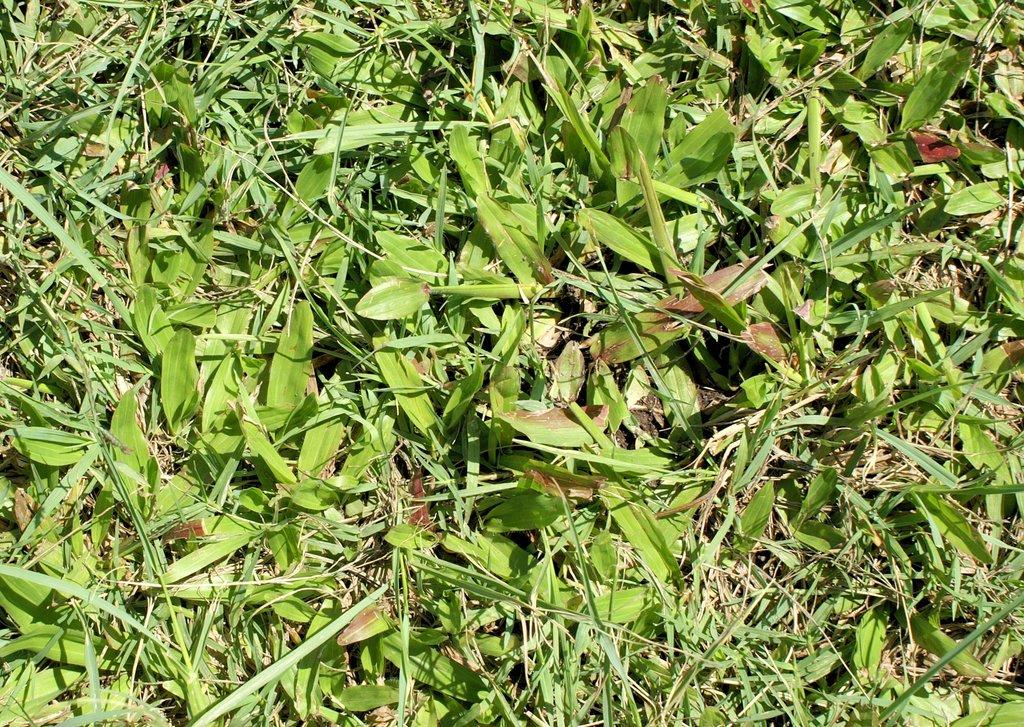What type of vegetation is present in the image? There is grass and leaves in the image. Can you describe the texture of the vegetation? The grass appears to be green and lush, while the leaves may have different textures depending on the type of plant they belong to. What type of stamp is featured in the image? There is no stamp present in the image; it only contains grass and leaves. 